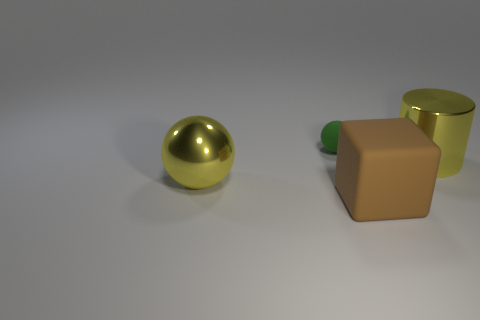Add 3 brown things. How many objects exist? 7 Subtract all yellow spheres. How many spheres are left? 1 Subtract 0 purple cubes. How many objects are left? 4 Subtract all cubes. How many objects are left? 3 Subtract all cyan cylinders. Subtract all green cubes. How many cylinders are left? 1 Subtract all gray blocks. How many green spheres are left? 1 Subtract all metallic cylinders. Subtract all tiny green rubber objects. How many objects are left? 2 Add 1 big yellow metal things. How many big yellow metal things are left? 3 Add 4 large blocks. How many large blocks exist? 5 